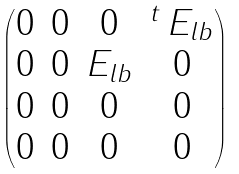Convert formula to latex. <formula><loc_0><loc_0><loc_500><loc_500>\begin{pmatrix} 0 & 0 & 0 & ^ { t } \, E _ { l b } \\ 0 & 0 & E _ { l b } & 0 \\ 0 & 0 & 0 & 0 \\ 0 & 0 & 0 & 0 \end{pmatrix}</formula> 